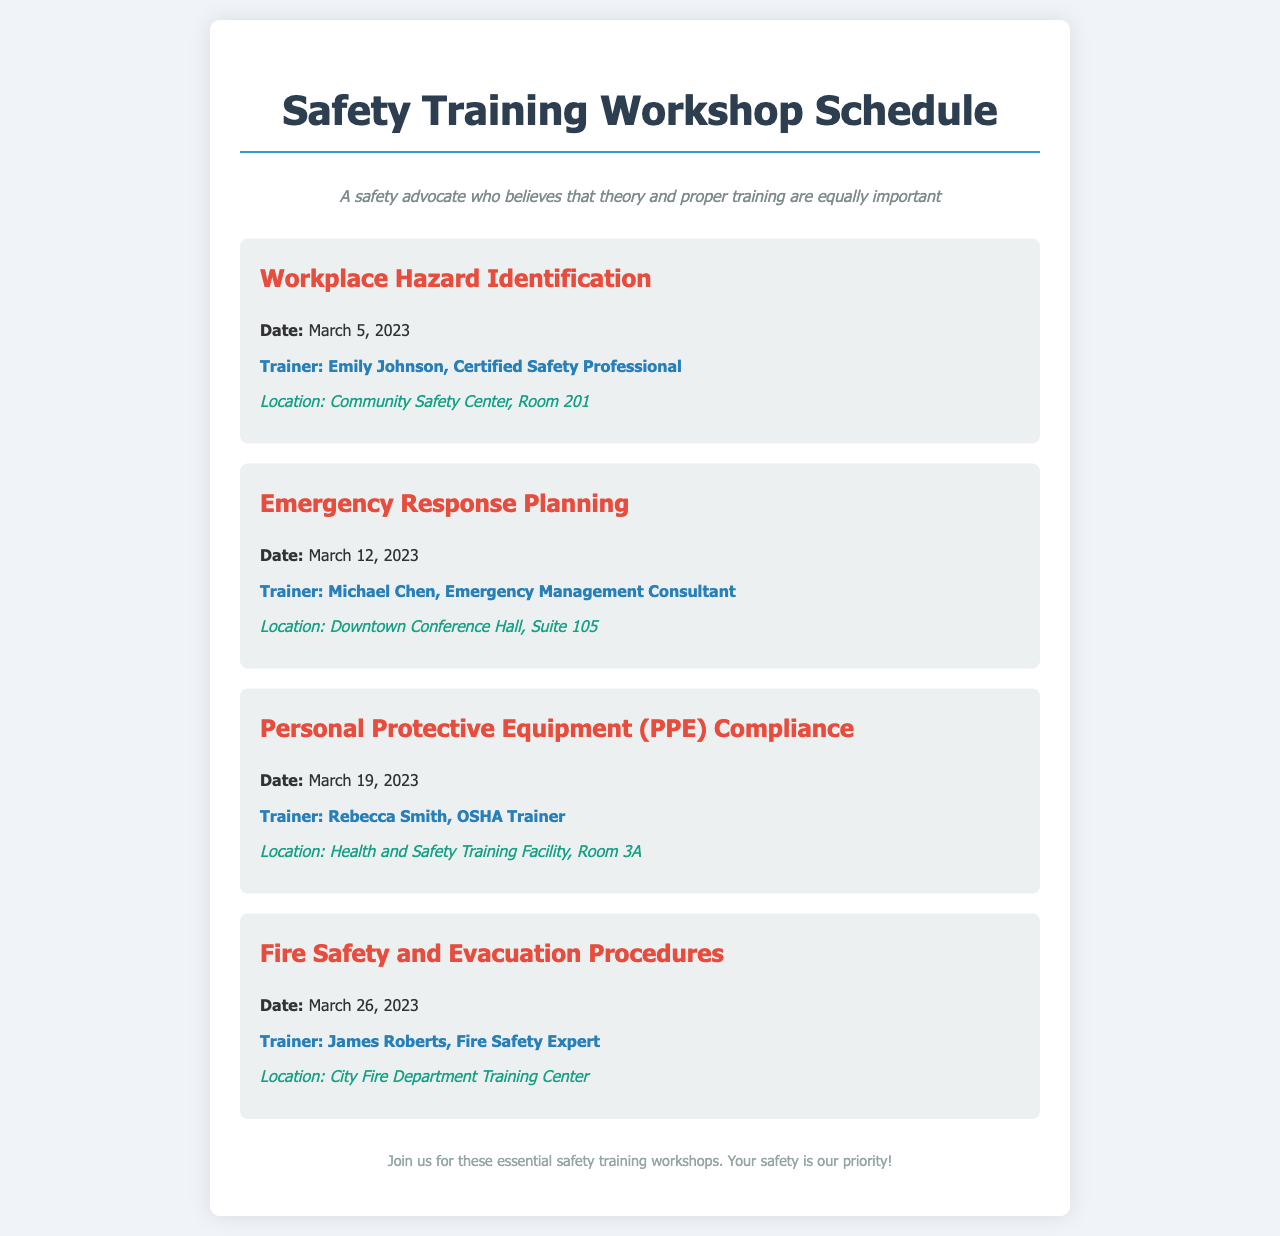What is the date of the Workplace Hazard Identification session? The document states that the Workplace Hazard Identification session is scheduled for March 5, 2023.
Answer: March 5, 2023 Who is the trainer for the Emergency Response Planning session? The document lists Michael Chen as the trainer for the Emergency Response Planning session.
Answer: Michael Chen Where will the Fire Safety and Evacuation Procedures session be held? According to the document, the Fire Safety and Evacuation Procedures session will take place at the City Fire Department Training Center.
Answer: City Fire Department Training Center How many workshops are scheduled for March 2023? The document outlines four sessions for March 2023: Workplace Hazard Identification, Emergency Response Planning, PPE Compliance, and Fire Safety.
Answer: Four What topic is covered on March 19, 2023? The document indicates that Personal Protective Equipment (PPE) Compliance will be the topic on March 19, 2023.
Answer: Personal Protective Equipment (PPE) Compliance Who is the trainer for the PPE Compliance session? The document specifies Rebecca Smith as the trainer for the Personal Protective Equipment (PPE) Compliance session.
Answer: Rebecca Smith What is the purpose of these workshops? The document highlights that the workshops are aimed at enhancing safety awareness and training.
Answer: Enhancing safety awareness and training 